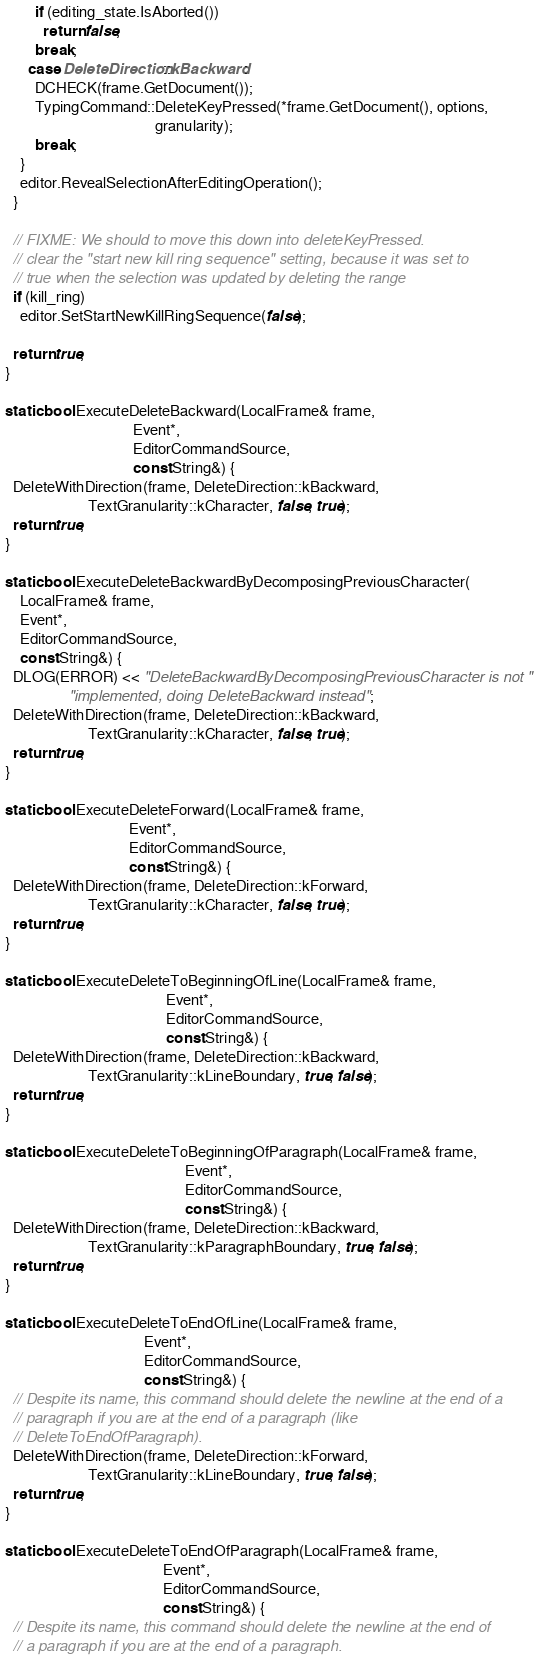Convert code to text. <code><loc_0><loc_0><loc_500><loc_500><_C++_>        if (editing_state.IsAborted())
          return false;
        break;
      case DeleteDirection::kBackward:
        DCHECK(frame.GetDocument());
        TypingCommand::DeleteKeyPressed(*frame.GetDocument(), options,
                                        granularity);
        break;
    }
    editor.RevealSelectionAfterEditingOperation();
  }

  // FIXME: We should to move this down into deleteKeyPressed.
  // clear the "start new kill ring sequence" setting, because it was set to
  // true when the selection was updated by deleting the range
  if (kill_ring)
    editor.SetStartNewKillRingSequence(false);

  return true;
}

static bool ExecuteDeleteBackward(LocalFrame& frame,
                                  Event*,
                                  EditorCommandSource,
                                  const String&) {
  DeleteWithDirection(frame, DeleteDirection::kBackward,
                      TextGranularity::kCharacter, false, true);
  return true;
}

static bool ExecuteDeleteBackwardByDecomposingPreviousCharacter(
    LocalFrame& frame,
    Event*,
    EditorCommandSource,
    const String&) {
  DLOG(ERROR) << "DeleteBackwardByDecomposingPreviousCharacter is not "
                 "implemented, doing DeleteBackward instead";
  DeleteWithDirection(frame, DeleteDirection::kBackward,
                      TextGranularity::kCharacter, false, true);
  return true;
}

static bool ExecuteDeleteForward(LocalFrame& frame,
                                 Event*,
                                 EditorCommandSource,
                                 const String&) {
  DeleteWithDirection(frame, DeleteDirection::kForward,
                      TextGranularity::kCharacter, false, true);
  return true;
}

static bool ExecuteDeleteToBeginningOfLine(LocalFrame& frame,
                                           Event*,
                                           EditorCommandSource,
                                           const String&) {
  DeleteWithDirection(frame, DeleteDirection::kBackward,
                      TextGranularity::kLineBoundary, true, false);
  return true;
}

static bool ExecuteDeleteToBeginningOfParagraph(LocalFrame& frame,
                                                Event*,
                                                EditorCommandSource,
                                                const String&) {
  DeleteWithDirection(frame, DeleteDirection::kBackward,
                      TextGranularity::kParagraphBoundary, true, false);
  return true;
}

static bool ExecuteDeleteToEndOfLine(LocalFrame& frame,
                                     Event*,
                                     EditorCommandSource,
                                     const String&) {
  // Despite its name, this command should delete the newline at the end of a
  // paragraph if you are at the end of a paragraph (like
  // DeleteToEndOfParagraph).
  DeleteWithDirection(frame, DeleteDirection::kForward,
                      TextGranularity::kLineBoundary, true, false);
  return true;
}

static bool ExecuteDeleteToEndOfParagraph(LocalFrame& frame,
                                          Event*,
                                          EditorCommandSource,
                                          const String&) {
  // Despite its name, this command should delete the newline at the end of
  // a paragraph if you are at the end of a paragraph.</code> 